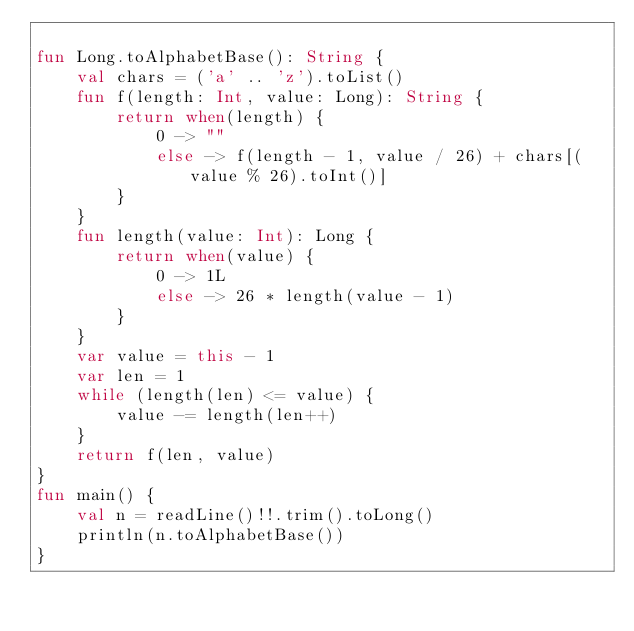Convert code to text. <code><loc_0><loc_0><loc_500><loc_500><_Kotlin_>
fun Long.toAlphabetBase(): String {
    val chars = ('a' .. 'z').toList()
    fun f(length: Int, value: Long): String {
        return when(length) {
            0 -> ""
            else -> f(length - 1, value / 26) + chars[(value % 26).toInt()]
        }
    }
    fun length(value: Int): Long {
        return when(value) {
            0 -> 1L
            else -> 26 * length(value - 1)
        }
    }
    var value = this - 1
    var len = 1
    while (length(len) <= value) {
        value -= length(len++)
    }
    return f(len, value)
}
fun main() {
    val n = readLine()!!.trim().toLong()
    println(n.toAlphabetBase())
}</code> 